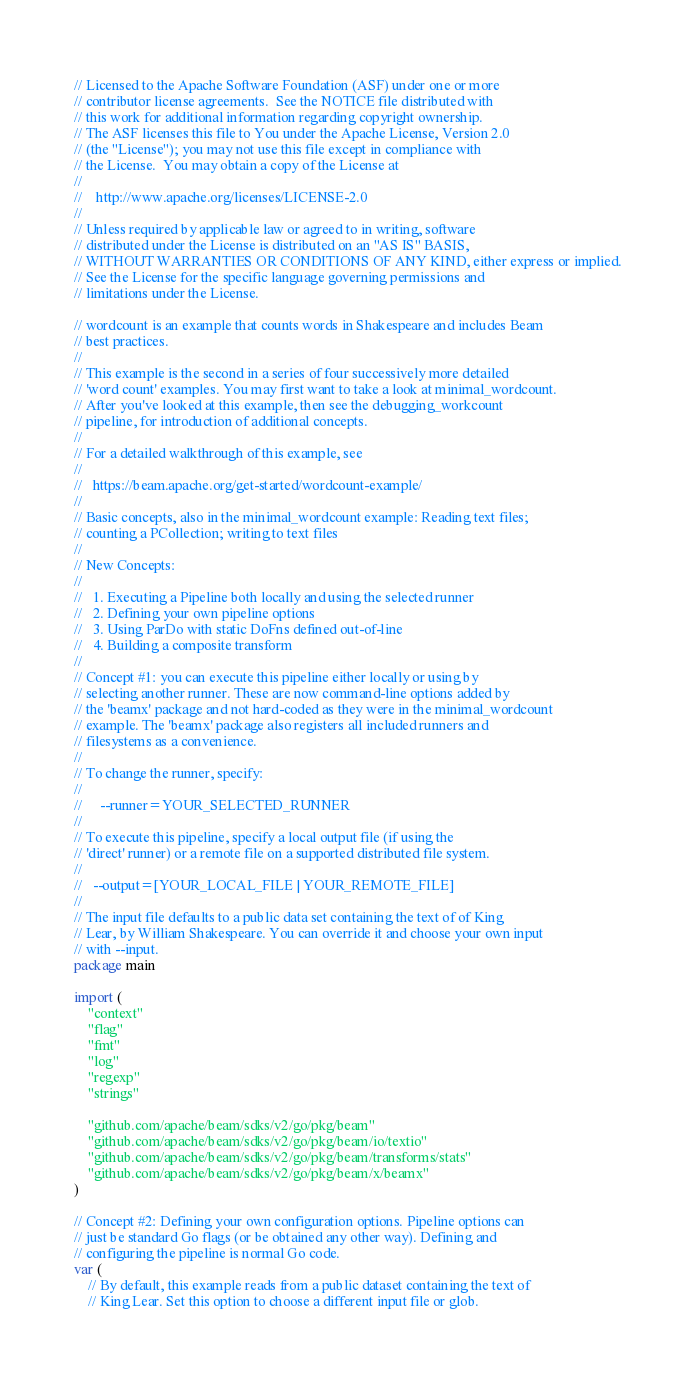<code> <loc_0><loc_0><loc_500><loc_500><_Go_>// Licensed to the Apache Software Foundation (ASF) under one or more
// contributor license agreements.  See the NOTICE file distributed with
// this work for additional information regarding copyright ownership.
// The ASF licenses this file to You under the Apache License, Version 2.0
// (the "License"); you may not use this file except in compliance with
// the License.  You may obtain a copy of the License at
//
//    http://www.apache.org/licenses/LICENSE-2.0
//
// Unless required by applicable law or agreed to in writing, software
// distributed under the License is distributed on an "AS IS" BASIS,
// WITHOUT WARRANTIES OR CONDITIONS OF ANY KIND, either express or implied.
// See the License for the specific language governing permissions and
// limitations under the License.

// wordcount is an example that counts words in Shakespeare and includes Beam
// best practices.
//
// This example is the second in a series of four successively more detailed
// 'word count' examples. You may first want to take a look at minimal_wordcount.
// After you've looked at this example, then see the debugging_workcount
// pipeline, for introduction of additional concepts.
//
// For a detailed walkthrough of this example, see
//
//   https://beam.apache.org/get-started/wordcount-example/
//
// Basic concepts, also in the minimal_wordcount example: Reading text files;
// counting a PCollection; writing to text files
//
// New Concepts:
//
//   1. Executing a Pipeline both locally and using the selected runner
//   2. Defining your own pipeline options
//   3. Using ParDo with static DoFns defined out-of-line
//   4. Building a composite transform
//
// Concept #1: you can execute this pipeline either locally or using by
// selecting another runner. These are now command-line options added by
// the 'beamx' package and not hard-coded as they were in the minimal_wordcount
// example. The 'beamx' package also registers all included runners and
// filesystems as a convenience.
//
// To change the runner, specify:
//
//     --runner=YOUR_SELECTED_RUNNER
//
// To execute this pipeline, specify a local output file (if using the
// 'direct' runner) or a remote file on a supported distributed file system.
//
//   --output=[YOUR_LOCAL_FILE | YOUR_REMOTE_FILE]
//
// The input file defaults to a public data set containing the text of of King
// Lear, by William Shakespeare. You can override it and choose your own input
// with --input.
package main

import (
	"context"
	"flag"
	"fmt"
	"log"
	"regexp"
	"strings"

	"github.com/apache/beam/sdks/v2/go/pkg/beam"
	"github.com/apache/beam/sdks/v2/go/pkg/beam/io/textio"
	"github.com/apache/beam/sdks/v2/go/pkg/beam/transforms/stats"
	"github.com/apache/beam/sdks/v2/go/pkg/beam/x/beamx"
)

// Concept #2: Defining your own configuration options. Pipeline options can
// just be standard Go flags (or be obtained any other way). Defining and
// configuring the pipeline is normal Go code.
var (
	// By default, this example reads from a public dataset containing the text of
	// King Lear. Set this option to choose a different input file or glob.</code> 